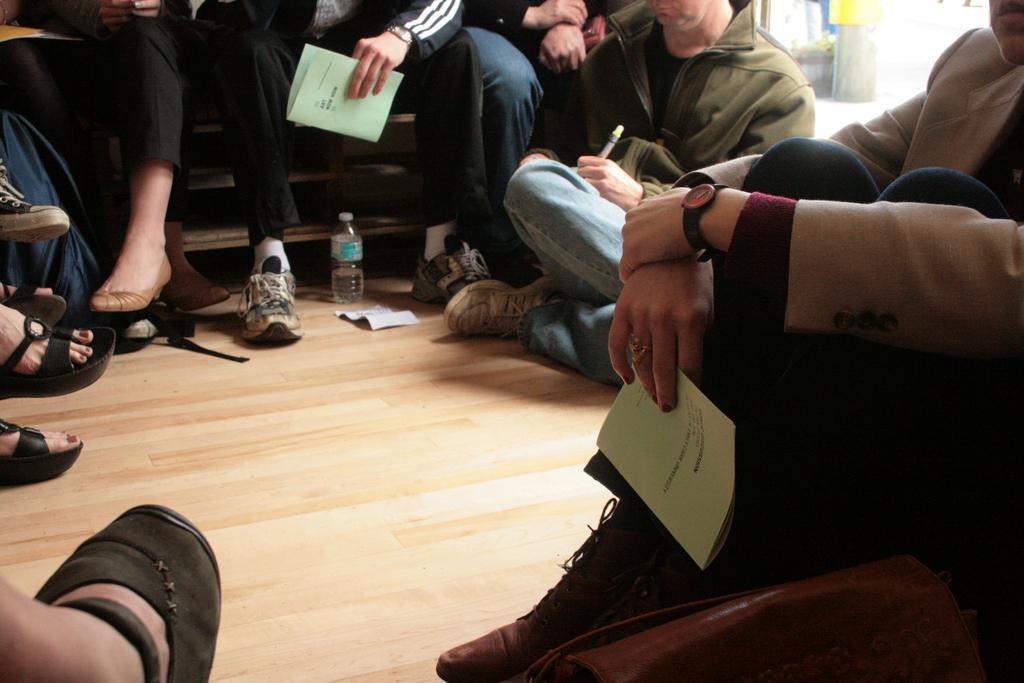How would you summarize this image in a sentence or two? In this picture we can see a group of people,here we can see a bottle and some people are holding papers,pen. 